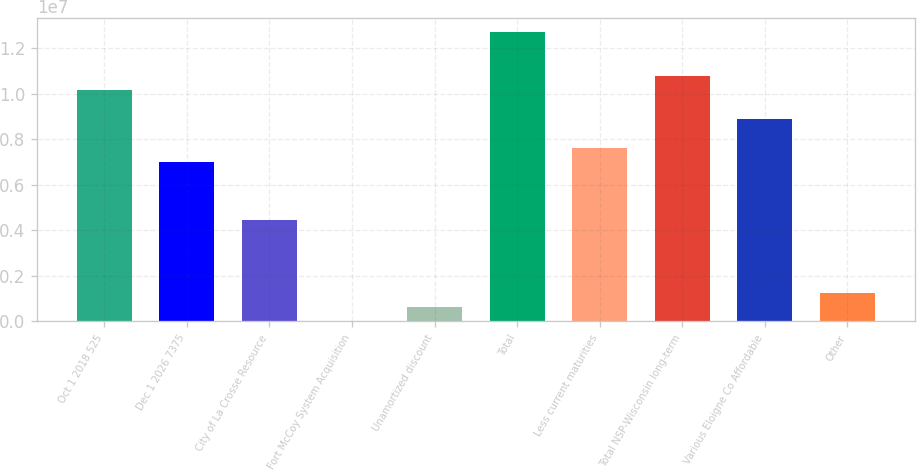<chart> <loc_0><loc_0><loc_500><loc_500><bar_chart><fcel>Oct 1 2018 525<fcel>Dec 1 2026 7375<fcel>City of La Crosse Resource<fcel>Fort McCoy System Acquisition<fcel>Unamortized discount<fcel>Total<fcel>Less current maturities<fcel>Total NSP-Wisconsin long-term<fcel>Various Eloigne Co Affordable<fcel>Other<nl><fcel>1.0147e+07<fcel>6.9763e+06<fcel>4.43974e+06<fcel>760<fcel>634900<fcel>1.26836e+07<fcel>7.61044e+06<fcel>1.07811e+07<fcel>8.87872e+06<fcel>1.26904e+06<nl></chart> 